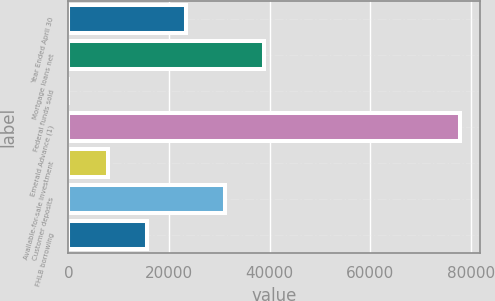Convert chart to OTSL. <chart><loc_0><loc_0><loc_500><loc_500><bar_chart><fcel>Year Ended April 30<fcel>Mortgage loans net<fcel>Federal funds sold<fcel>Emerald Advance (1)<fcel>Available-for-sale investment<fcel>Customer deposits<fcel>FHLB borrowing<nl><fcel>23373.6<fcel>38950<fcel>9<fcel>77891<fcel>7797.2<fcel>31161.8<fcel>15585.4<nl></chart> 